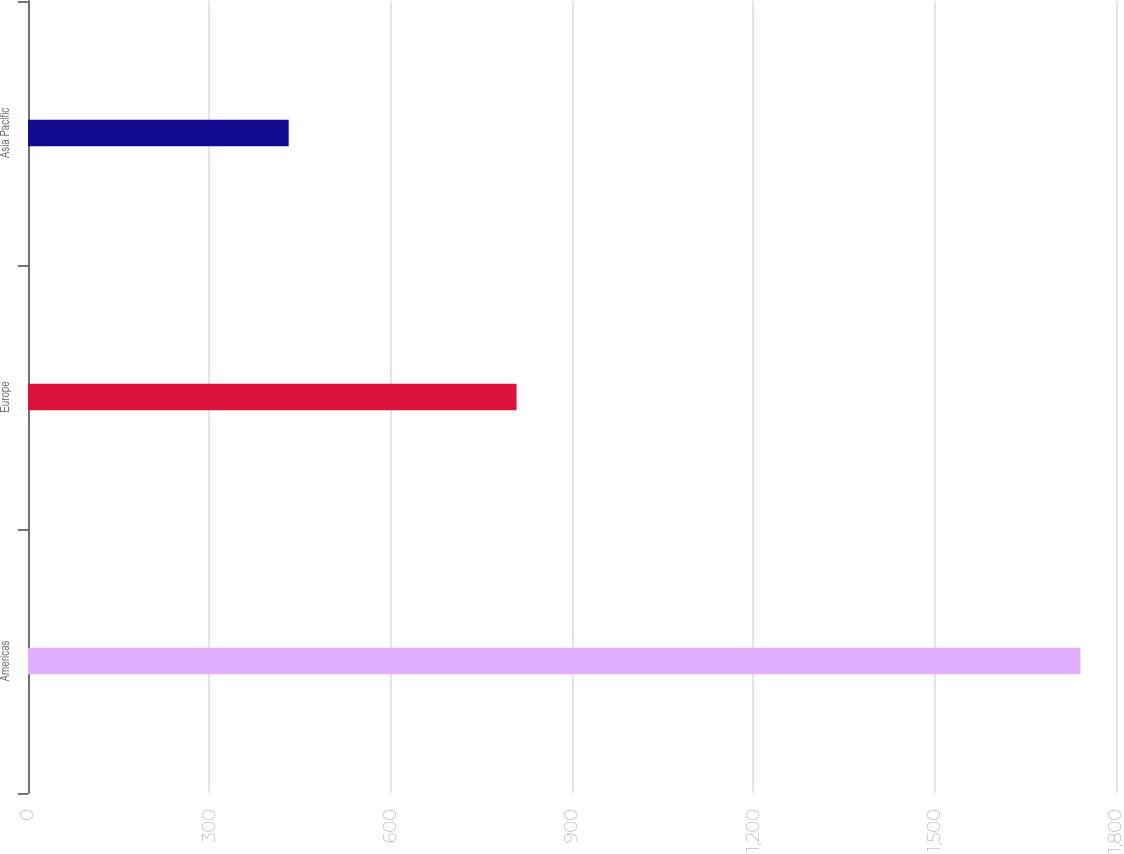Convert chart. <chart><loc_0><loc_0><loc_500><loc_500><bar_chart><fcel>Americas<fcel>Europe<fcel>Asia Pacific<nl><fcel>1741.3<fcel>808.3<fcel>431.3<nl></chart> 